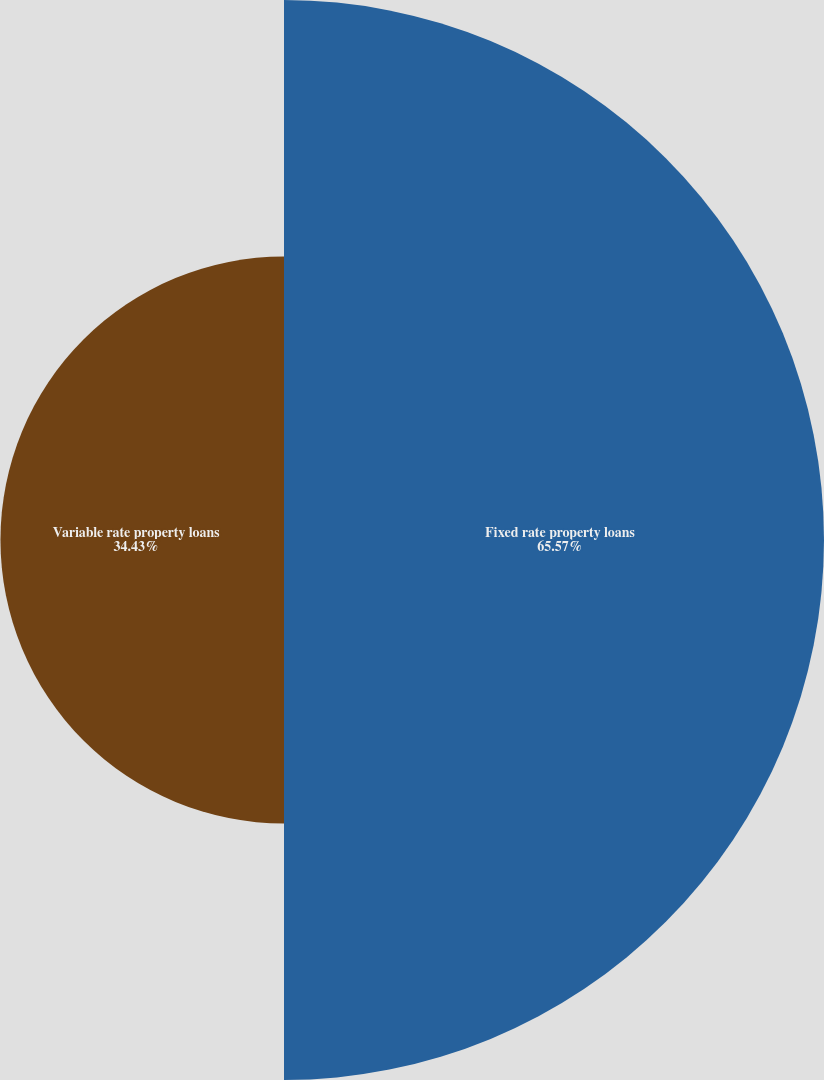Convert chart to OTSL. <chart><loc_0><loc_0><loc_500><loc_500><pie_chart><fcel>Fixed rate property loans<fcel>Variable rate property loans<nl><fcel>65.57%<fcel>34.43%<nl></chart> 